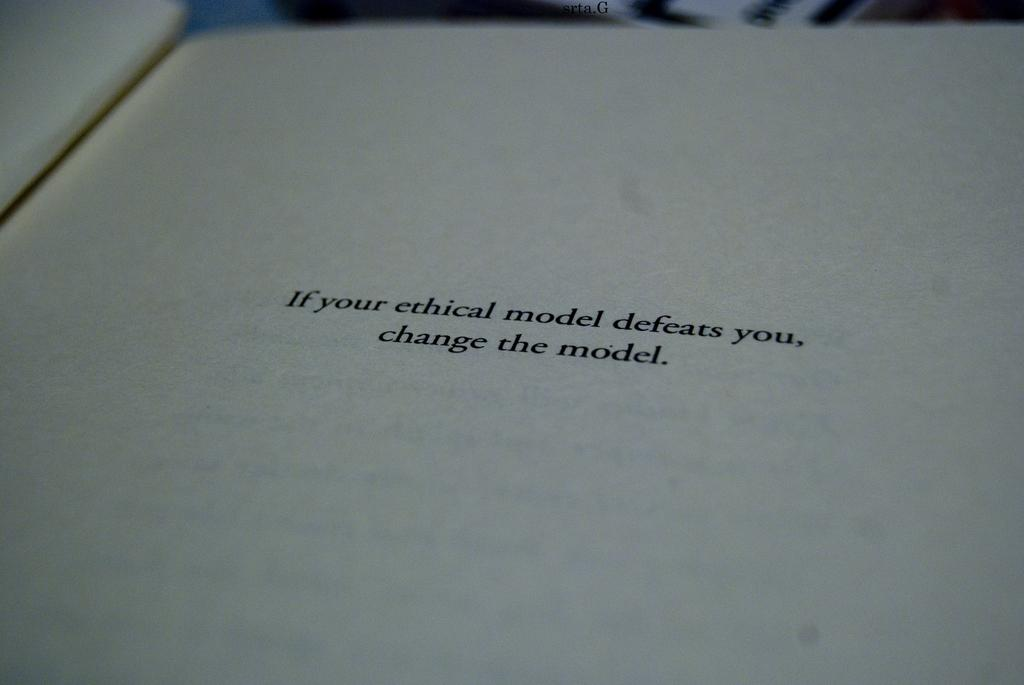Provide a one-sentence caption for the provided image. A notation page of a book that says if your ethical model defeats you, change the model. 